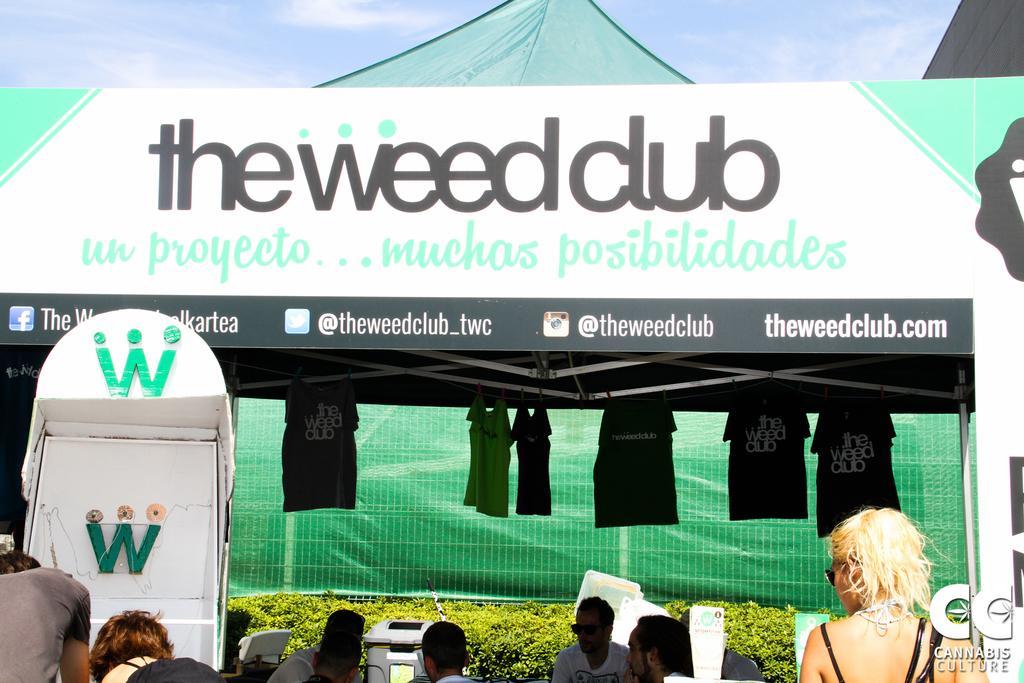How would you summarize this image in a sentence or two? In this picture I can see the shed and banner. At the bottom I can see some men were sitting near to the table and plants. In the bottom right corner there is a woman who is wearing goggles and black dress, beside her I can see the watermark. In bottom left corner there is a man who is wearing t-shirt. he is standing near the booth. At the top I can see the sky and clouds. In the background I can see the blue green color plastic cover and its looks like a tent. Under the shade, I can see many t-shirt which are hanging from the roof. 